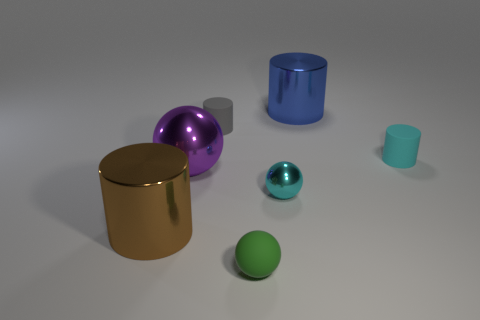Do the large metal thing that is on the right side of the green object and the small cyan matte thing have the same shape?
Keep it short and to the point. Yes. There is a thing that is the same color as the tiny metal ball; what size is it?
Offer a very short reply. Small. How many brown objects are cylinders or tiny shiny balls?
Give a very brief answer. 1. How many other things are the same shape as the gray matte object?
Provide a short and direct response. 3. What shape is the thing that is in front of the big blue metallic thing and on the right side of the small cyan shiny ball?
Keep it short and to the point. Cylinder. Are there any large blue shiny things left of the brown thing?
Make the answer very short. No. What is the size of the green thing that is the same shape as the big purple object?
Provide a short and direct response. Small. Is there anything else that is the same size as the brown metallic thing?
Offer a terse response. Yes. Does the green matte object have the same shape as the small cyan matte object?
Provide a succinct answer. No. There is a matte cylinder in front of the small rubber cylinder that is left of the small cyan cylinder; what size is it?
Your answer should be very brief. Small. 